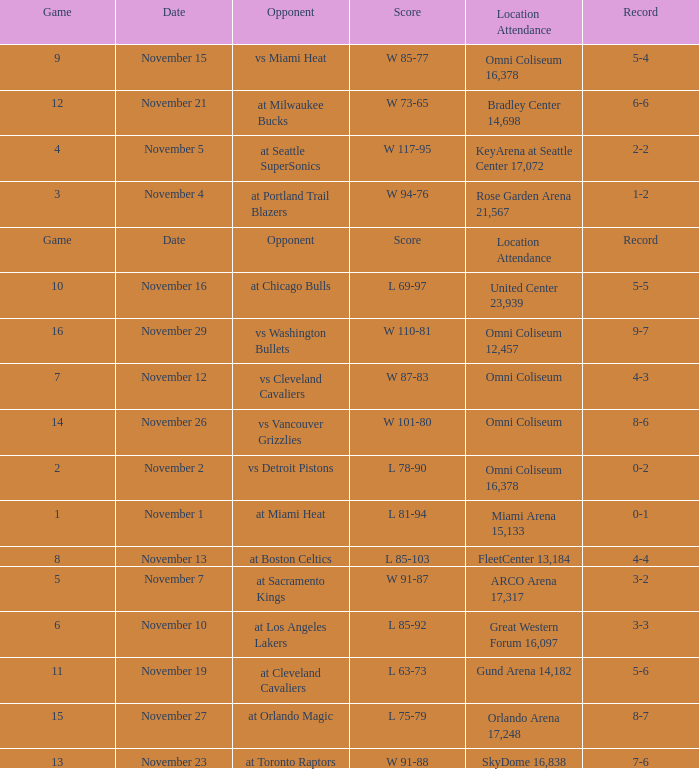Write the full table. {'header': ['Game', 'Date', 'Opponent', 'Score', 'Location Attendance', 'Record'], 'rows': [['9', 'November 15', 'vs Miami Heat', 'W 85-77', 'Omni Coliseum 16,378', '5-4'], ['12', 'November 21', 'at Milwaukee Bucks', 'W 73-65', 'Bradley Center 14,698', '6-6'], ['4', 'November 5', 'at Seattle SuperSonics', 'W 117-95', 'KeyArena at Seattle Center 17,072', '2-2'], ['3', 'November 4', 'at Portland Trail Blazers', 'W 94-76', 'Rose Garden Arena 21,567', '1-2'], ['Game', 'Date', 'Opponent', 'Score', 'Location Attendance', 'Record'], ['10', 'November 16', 'at Chicago Bulls', 'L 69-97', 'United Center 23,939', '5-5'], ['16', 'November 29', 'vs Washington Bullets', 'W 110-81', 'Omni Coliseum 12,457', '9-7'], ['7', 'November 12', 'vs Cleveland Cavaliers', 'W 87-83', 'Omni Coliseum', '4-3'], ['14', 'November 26', 'vs Vancouver Grizzlies', 'W 101-80', 'Omni Coliseum', '8-6'], ['2', 'November 2', 'vs Detroit Pistons', 'L 78-90', 'Omni Coliseum 16,378', '0-2'], ['1', 'November 1', 'at Miami Heat', 'L 81-94', 'Miami Arena 15,133', '0-1'], ['8', 'November 13', 'at Boston Celtics', 'L 85-103', 'FleetCenter 13,184', '4-4'], ['5', 'November 7', 'at Sacramento Kings', 'W 91-87', 'ARCO Arena 17,317', '3-2'], ['6', 'November 10', 'at Los Angeles Lakers', 'L 85-92', 'Great Western Forum 16,097', '3-3'], ['11', 'November 19', 'at Cleveland Cavaliers', 'L 63-73', 'Gund Arena 14,182', '5-6'], ['15', 'November 27', 'at Orlando Magic', 'L 75-79', 'Orlando Arena 17,248', '8-7'], ['13', 'November 23', 'at Toronto Raptors', 'W 91-88', 'SkyDome 16,838', '7-6']]} On what date was game 3? November 4. 